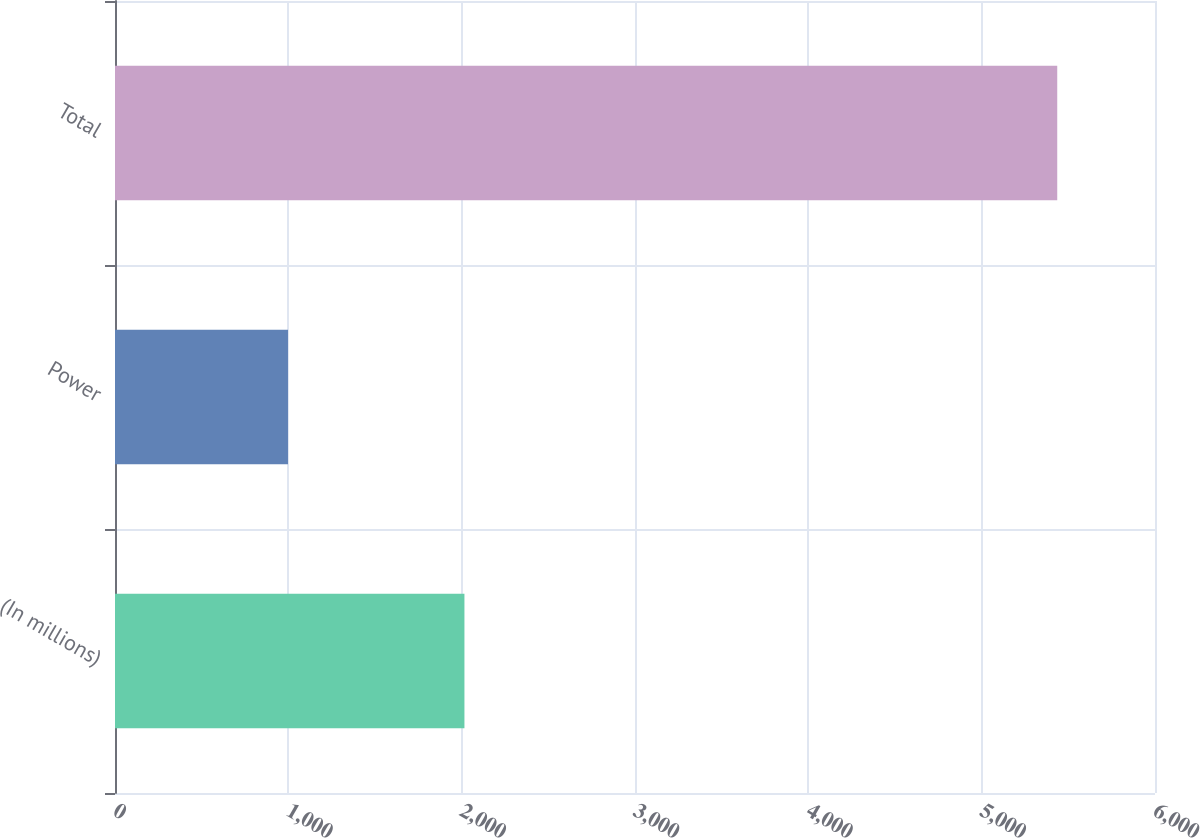Convert chart. <chart><loc_0><loc_0><loc_500><loc_500><bar_chart><fcel>(In millions)<fcel>Power<fcel>Total<nl><fcel>2016<fcel>998<fcel>5436<nl></chart> 